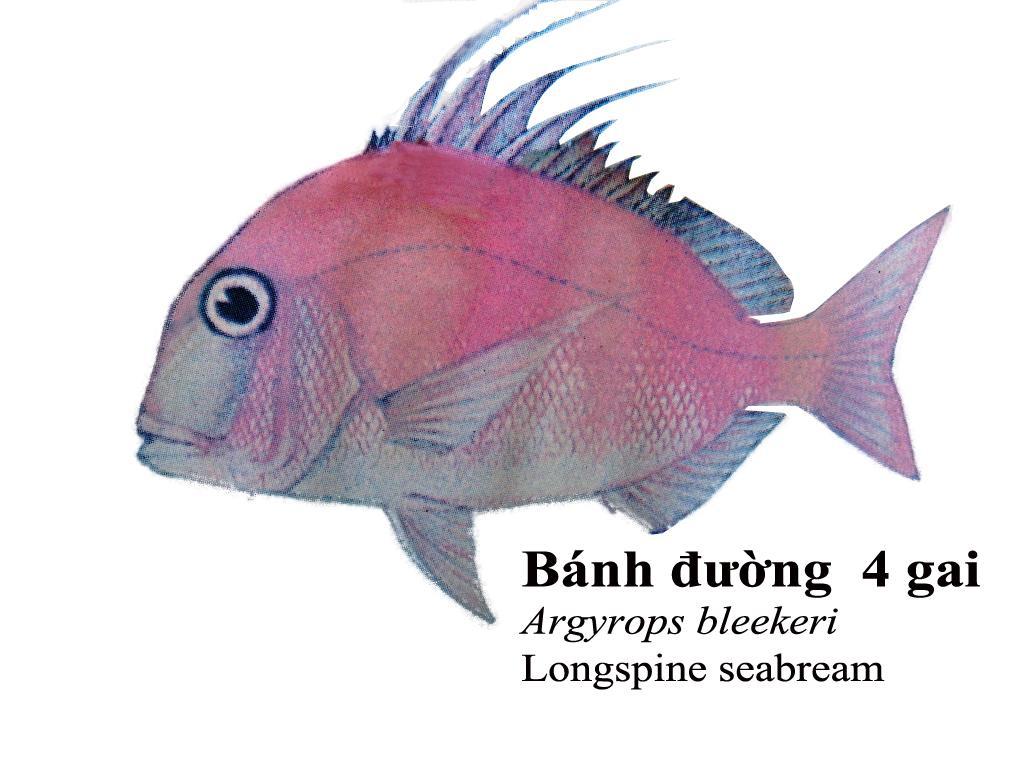Can you describe this image briefly? This is a painting in this image in the center there is one fish, and at the bottom of the image there is some text. 